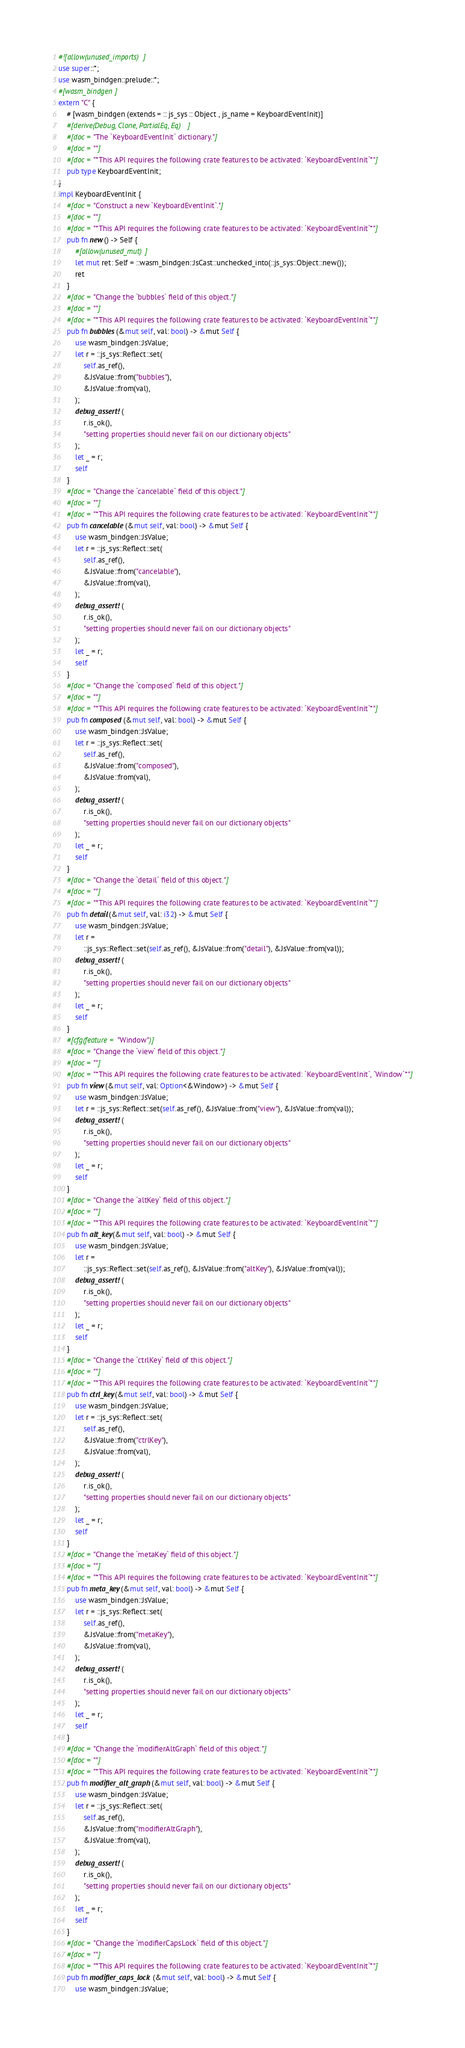<code> <loc_0><loc_0><loc_500><loc_500><_Rust_>#![allow(unused_imports)]
use super::*;
use wasm_bindgen::prelude::*;
#[wasm_bindgen]
extern "C" {
    # [wasm_bindgen (extends = :: js_sys :: Object , js_name = KeyboardEventInit)]
    #[derive(Debug, Clone, PartialEq, Eq)]
    #[doc = "The `KeyboardEventInit` dictionary."]
    #[doc = ""]
    #[doc = "*This API requires the following crate features to be activated: `KeyboardEventInit`*"]
    pub type KeyboardEventInit;
}
impl KeyboardEventInit {
    #[doc = "Construct a new `KeyboardEventInit`."]
    #[doc = ""]
    #[doc = "*This API requires the following crate features to be activated: `KeyboardEventInit`*"]
    pub fn new() -> Self {
        #[allow(unused_mut)]
        let mut ret: Self = ::wasm_bindgen::JsCast::unchecked_into(::js_sys::Object::new());
        ret
    }
    #[doc = "Change the `bubbles` field of this object."]
    #[doc = ""]
    #[doc = "*This API requires the following crate features to be activated: `KeyboardEventInit`*"]
    pub fn bubbles(&mut self, val: bool) -> &mut Self {
        use wasm_bindgen::JsValue;
        let r = ::js_sys::Reflect::set(
            self.as_ref(),
            &JsValue::from("bubbles"),
            &JsValue::from(val),
        );
        debug_assert!(
            r.is_ok(),
            "setting properties should never fail on our dictionary objects"
        );
        let _ = r;
        self
    }
    #[doc = "Change the `cancelable` field of this object."]
    #[doc = ""]
    #[doc = "*This API requires the following crate features to be activated: `KeyboardEventInit`*"]
    pub fn cancelable(&mut self, val: bool) -> &mut Self {
        use wasm_bindgen::JsValue;
        let r = ::js_sys::Reflect::set(
            self.as_ref(),
            &JsValue::from("cancelable"),
            &JsValue::from(val),
        );
        debug_assert!(
            r.is_ok(),
            "setting properties should never fail on our dictionary objects"
        );
        let _ = r;
        self
    }
    #[doc = "Change the `composed` field of this object."]
    #[doc = ""]
    #[doc = "*This API requires the following crate features to be activated: `KeyboardEventInit`*"]
    pub fn composed(&mut self, val: bool) -> &mut Self {
        use wasm_bindgen::JsValue;
        let r = ::js_sys::Reflect::set(
            self.as_ref(),
            &JsValue::from("composed"),
            &JsValue::from(val),
        );
        debug_assert!(
            r.is_ok(),
            "setting properties should never fail on our dictionary objects"
        );
        let _ = r;
        self
    }
    #[doc = "Change the `detail` field of this object."]
    #[doc = ""]
    #[doc = "*This API requires the following crate features to be activated: `KeyboardEventInit`*"]
    pub fn detail(&mut self, val: i32) -> &mut Self {
        use wasm_bindgen::JsValue;
        let r =
            ::js_sys::Reflect::set(self.as_ref(), &JsValue::from("detail"), &JsValue::from(val));
        debug_assert!(
            r.is_ok(),
            "setting properties should never fail on our dictionary objects"
        );
        let _ = r;
        self
    }
    #[cfg(feature = "Window")]
    #[doc = "Change the `view` field of this object."]
    #[doc = ""]
    #[doc = "*This API requires the following crate features to be activated: `KeyboardEventInit`, `Window`*"]
    pub fn view(&mut self, val: Option<&Window>) -> &mut Self {
        use wasm_bindgen::JsValue;
        let r = ::js_sys::Reflect::set(self.as_ref(), &JsValue::from("view"), &JsValue::from(val));
        debug_assert!(
            r.is_ok(),
            "setting properties should never fail on our dictionary objects"
        );
        let _ = r;
        self
    }
    #[doc = "Change the `altKey` field of this object."]
    #[doc = ""]
    #[doc = "*This API requires the following crate features to be activated: `KeyboardEventInit`*"]
    pub fn alt_key(&mut self, val: bool) -> &mut Self {
        use wasm_bindgen::JsValue;
        let r =
            ::js_sys::Reflect::set(self.as_ref(), &JsValue::from("altKey"), &JsValue::from(val));
        debug_assert!(
            r.is_ok(),
            "setting properties should never fail on our dictionary objects"
        );
        let _ = r;
        self
    }
    #[doc = "Change the `ctrlKey` field of this object."]
    #[doc = ""]
    #[doc = "*This API requires the following crate features to be activated: `KeyboardEventInit`*"]
    pub fn ctrl_key(&mut self, val: bool) -> &mut Self {
        use wasm_bindgen::JsValue;
        let r = ::js_sys::Reflect::set(
            self.as_ref(),
            &JsValue::from("ctrlKey"),
            &JsValue::from(val),
        );
        debug_assert!(
            r.is_ok(),
            "setting properties should never fail on our dictionary objects"
        );
        let _ = r;
        self
    }
    #[doc = "Change the `metaKey` field of this object."]
    #[doc = ""]
    #[doc = "*This API requires the following crate features to be activated: `KeyboardEventInit`*"]
    pub fn meta_key(&mut self, val: bool) -> &mut Self {
        use wasm_bindgen::JsValue;
        let r = ::js_sys::Reflect::set(
            self.as_ref(),
            &JsValue::from("metaKey"),
            &JsValue::from(val),
        );
        debug_assert!(
            r.is_ok(),
            "setting properties should never fail on our dictionary objects"
        );
        let _ = r;
        self
    }
    #[doc = "Change the `modifierAltGraph` field of this object."]
    #[doc = ""]
    #[doc = "*This API requires the following crate features to be activated: `KeyboardEventInit`*"]
    pub fn modifier_alt_graph(&mut self, val: bool) -> &mut Self {
        use wasm_bindgen::JsValue;
        let r = ::js_sys::Reflect::set(
            self.as_ref(),
            &JsValue::from("modifierAltGraph"),
            &JsValue::from(val),
        );
        debug_assert!(
            r.is_ok(),
            "setting properties should never fail on our dictionary objects"
        );
        let _ = r;
        self
    }
    #[doc = "Change the `modifierCapsLock` field of this object."]
    #[doc = ""]
    #[doc = "*This API requires the following crate features to be activated: `KeyboardEventInit`*"]
    pub fn modifier_caps_lock(&mut self, val: bool) -> &mut Self {
        use wasm_bindgen::JsValue;</code> 